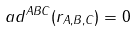Convert formula to latex. <formula><loc_0><loc_0><loc_500><loc_500>a d ^ { A B C } ( r _ { A , B , C } ) = 0</formula> 